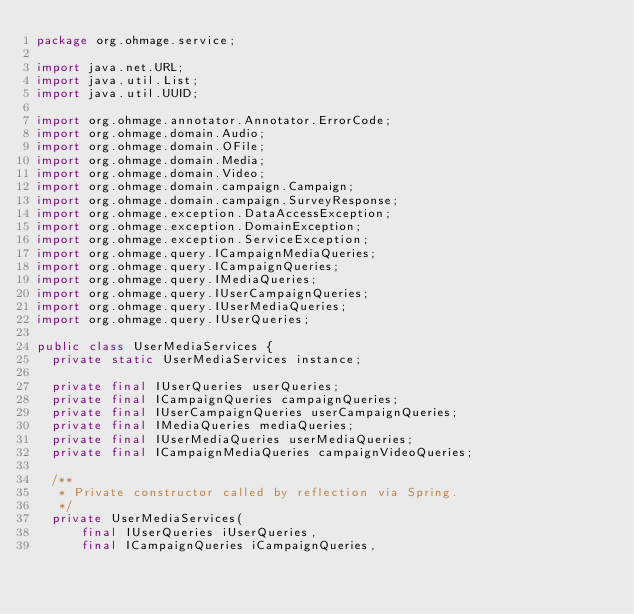<code> <loc_0><loc_0><loc_500><loc_500><_Java_>package org.ohmage.service;

import java.net.URL;
import java.util.List;
import java.util.UUID;

import org.ohmage.annotator.Annotator.ErrorCode;
import org.ohmage.domain.Audio;
import org.ohmage.domain.OFile;
import org.ohmage.domain.Media;
import org.ohmage.domain.Video;
import org.ohmage.domain.campaign.Campaign;
import org.ohmage.domain.campaign.SurveyResponse;
import org.ohmage.exception.DataAccessException;
import org.ohmage.exception.DomainException;
import org.ohmage.exception.ServiceException;
import org.ohmage.query.ICampaignMediaQueries;
import org.ohmage.query.ICampaignQueries;
import org.ohmage.query.IMediaQueries;
import org.ohmage.query.IUserCampaignQueries;
import org.ohmage.query.IUserMediaQueries;
import org.ohmage.query.IUserQueries;

public class UserMediaServices {
	private static UserMediaServices instance;
	
	private final IUserQueries userQueries;
	private final ICampaignQueries campaignQueries;
	private final IUserCampaignQueries userCampaignQueries;
	private final IMediaQueries mediaQueries;
	private final IUserMediaQueries userMediaQueries;
	private final ICampaignMediaQueries campaignVideoQueries;
	
	/**
	 * Private constructor called by reflection via Spring.
	 */
	private UserMediaServices(
			final IUserQueries iUserQueries,
			final ICampaignQueries iCampaignQueries,</code> 